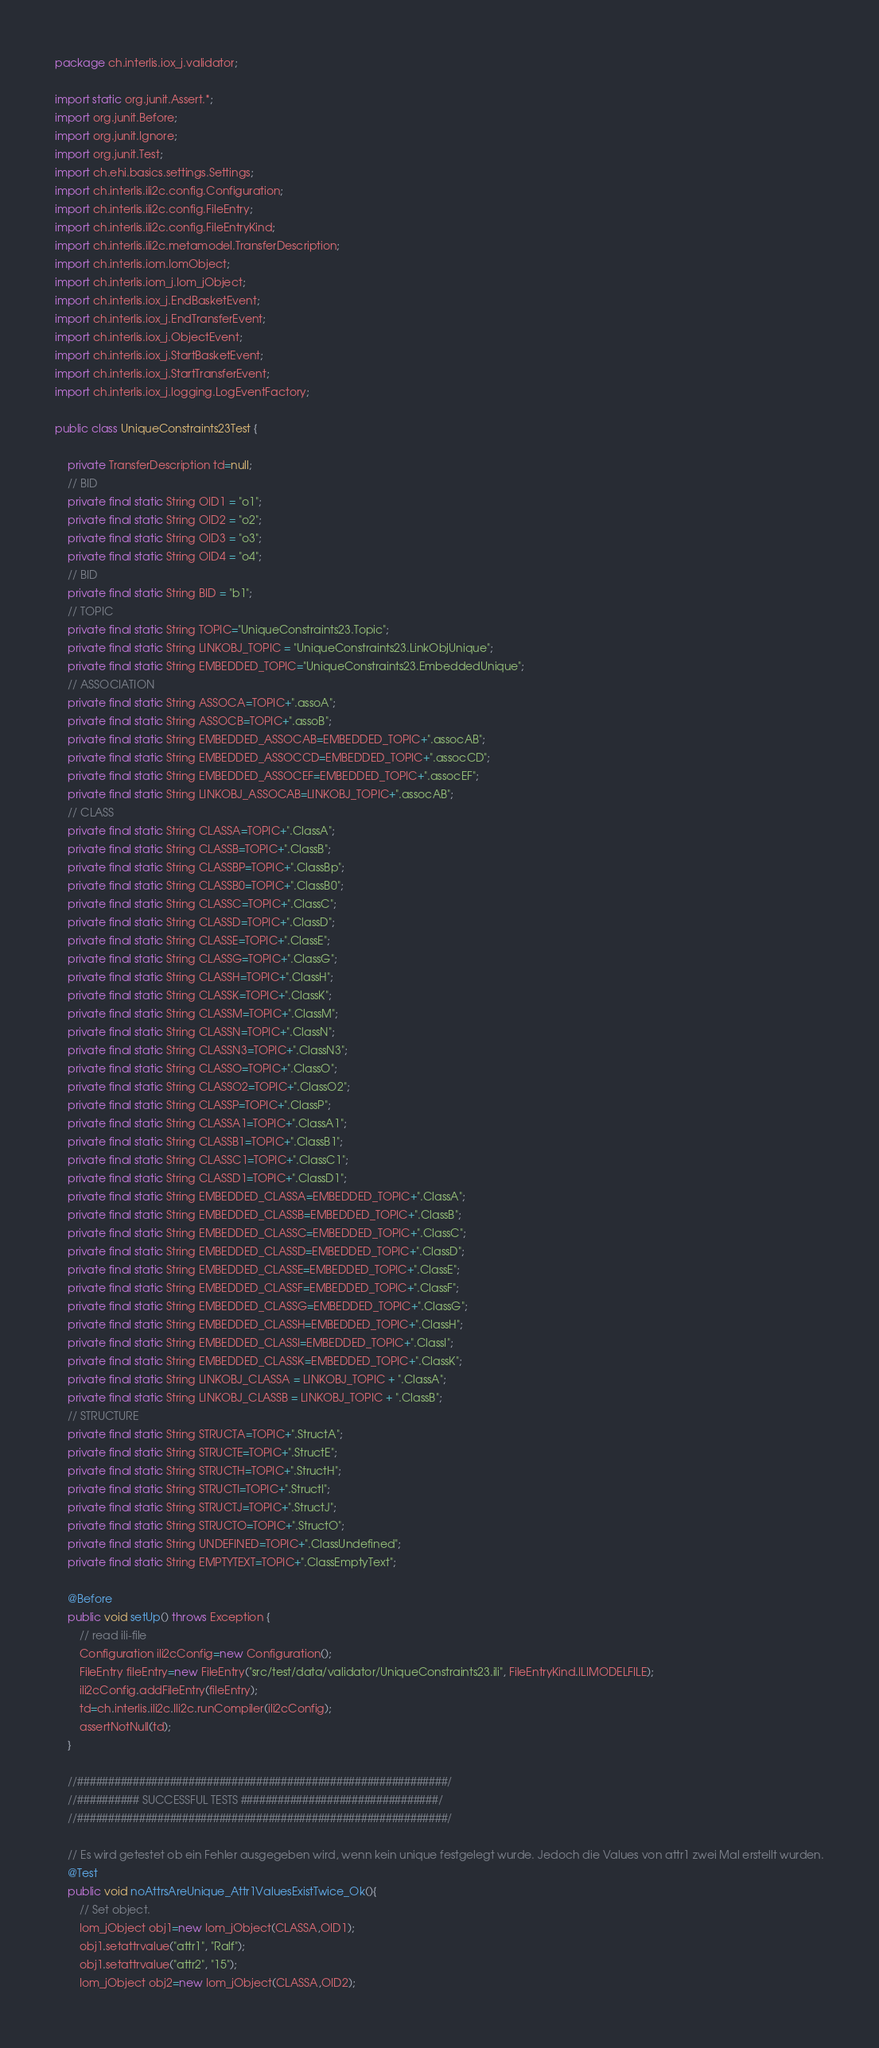Convert code to text. <code><loc_0><loc_0><loc_500><loc_500><_Java_>package ch.interlis.iox_j.validator;

import static org.junit.Assert.*;
import org.junit.Before;
import org.junit.Ignore;
import org.junit.Test;
import ch.ehi.basics.settings.Settings;
import ch.interlis.ili2c.config.Configuration;
import ch.interlis.ili2c.config.FileEntry;
import ch.interlis.ili2c.config.FileEntryKind;
import ch.interlis.ili2c.metamodel.TransferDescription;
import ch.interlis.iom.IomObject;
import ch.interlis.iom_j.Iom_jObject;
import ch.interlis.iox_j.EndBasketEvent;
import ch.interlis.iox_j.EndTransferEvent;
import ch.interlis.iox_j.ObjectEvent;
import ch.interlis.iox_j.StartBasketEvent;
import ch.interlis.iox_j.StartTransferEvent;
import ch.interlis.iox_j.logging.LogEventFactory;

public class UniqueConstraints23Test {

	private TransferDescription td=null;
	// BID
	private final static String OID1 = "o1";
	private final static String OID2 = "o2";
	private final static String OID3 = "o3";
	private final static String OID4 = "o4";
	// BID
	private final static String BID = "b1";
	// TOPIC
	private final static String TOPIC="UniqueConstraints23.Topic";
	private final static String LINKOBJ_TOPIC = "UniqueConstraints23.LinkObjUnique";
	private final static String EMBEDDED_TOPIC="UniqueConstraints23.EmbeddedUnique";
	// ASSOCIATION
	private final static String ASSOCA=TOPIC+".assoA";
	private final static String ASSOCB=TOPIC+".assoB";
	private final static String EMBEDDED_ASSOCAB=EMBEDDED_TOPIC+".assocAB";
	private final static String EMBEDDED_ASSOCCD=EMBEDDED_TOPIC+".assocCD";
	private final static String EMBEDDED_ASSOCEF=EMBEDDED_TOPIC+".assocEF";
	private final static String LINKOBJ_ASSOCAB=LINKOBJ_TOPIC+".assocAB";
	// CLASS
	private final static String CLASSA=TOPIC+".ClassA";
	private final static String CLASSB=TOPIC+".ClassB";
	private final static String CLASSBP=TOPIC+".ClassBp";
	private final static String CLASSB0=TOPIC+".ClassB0";
	private final static String CLASSC=TOPIC+".ClassC";
	private final static String CLASSD=TOPIC+".ClassD";
	private final static String CLASSE=TOPIC+".ClassE";
	private final static String CLASSG=TOPIC+".ClassG";
	private final static String CLASSH=TOPIC+".ClassH";
	private final static String CLASSK=TOPIC+".ClassK";
	private final static String CLASSM=TOPIC+".ClassM";
	private final static String CLASSN=TOPIC+".ClassN";
	private final static String CLASSN3=TOPIC+".ClassN3";
	private final static String CLASSO=TOPIC+".ClassO";
	private final static String CLASSO2=TOPIC+".ClassO2";
	private final static String CLASSP=TOPIC+".ClassP";
	private final static String CLASSA1=TOPIC+".ClassA1";
	private final static String CLASSB1=TOPIC+".ClassB1";
	private final static String CLASSC1=TOPIC+".ClassC1";
	private final static String CLASSD1=TOPIC+".ClassD1";
	private final static String EMBEDDED_CLASSA=EMBEDDED_TOPIC+".ClassA";
	private final static String EMBEDDED_CLASSB=EMBEDDED_TOPIC+".ClassB";
	private final static String EMBEDDED_CLASSC=EMBEDDED_TOPIC+".ClassC";
	private final static String EMBEDDED_CLASSD=EMBEDDED_TOPIC+".ClassD";
	private final static String EMBEDDED_CLASSE=EMBEDDED_TOPIC+".ClassE";
	private final static String EMBEDDED_CLASSF=EMBEDDED_TOPIC+".ClassF";
    private final static String EMBEDDED_CLASSG=EMBEDDED_TOPIC+".ClassG";
    private final static String EMBEDDED_CLASSH=EMBEDDED_TOPIC+".ClassH";
    private final static String EMBEDDED_CLASSI=EMBEDDED_TOPIC+".ClassI";
    private final static String EMBEDDED_CLASSK=EMBEDDED_TOPIC+".ClassK";
	private final static String LINKOBJ_CLASSA = LINKOBJ_TOPIC + ".ClassA";
	private final static String LINKOBJ_CLASSB = LINKOBJ_TOPIC + ".ClassB";
	// STRUCTURE
	private final static String STRUCTA=TOPIC+".StructA";
	private final static String STRUCTE=TOPIC+".StructE";
	private final static String STRUCTH=TOPIC+".StructH";
	private final static String STRUCTI=TOPIC+".StructI";
	private final static String STRUCTJ=TOPIC+".StructJ";
	private final static String STRUCTO=TOPIC+".StructO";
	private final static String UNDEFINED=TOPIC+".ClassUndefined";
	private final static String EMPTYTEXT=TOPIC+".ClassEmptyText";
	
	@Before
	public void setUp() throws Exception {
		// read ili-file
		Configuration ili2cConfig=new Configuration();
		FileEntry fileEntry=new FileEntry("src/test/data/validator/UniqueConstraints23.ili", FileEntryKind.ILIMODELFILE);
		ili2cConfig.addFileEntry(fileEntry);
		td=ch.interlis.ili2c.Ili2c.runCompiler(ili2cConfig);
		assertNotNull(td);
	}
	
	//############################################################/
	//########## SUCCESSFUL TESTS ################################/
	//############################################################/

	// Es wird getestet ob ein Fehler ausgegeben wird, wenn kein unique festgelegt wurde. Jedoch die Values von attr1 zwei Mal erstellt wurden.
	@Test
	public void noAttrsAreUnique_Attr1ValuesExistTwice_Ok(){
		// Set object.
		Iom_jObject obj1=new Iom_jObject(CLASSA,OID1);
		obj1.setattrvalue("attr1", "Ralf");
		obj1.setattrvalue("attr2", "15");
		Iom_jObject obj2=new Iom_jObject(CLASSA,OID2);</code> 